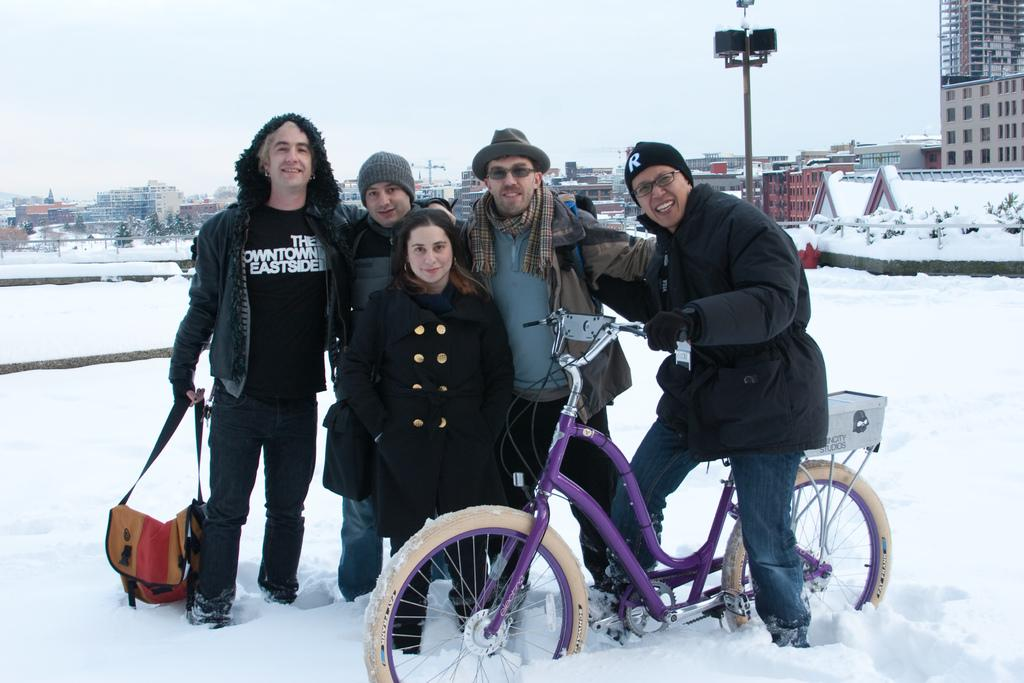What is the main subject of the image? There are people in the center of the image. What is the condition of the ground in the image? There is snow on the floor. What can be seen in the background of the image? There are buildings in the background of the image. What type of celery is being used as a sack by the authority figure in the image? There is no celery or authority figure present in the image. 